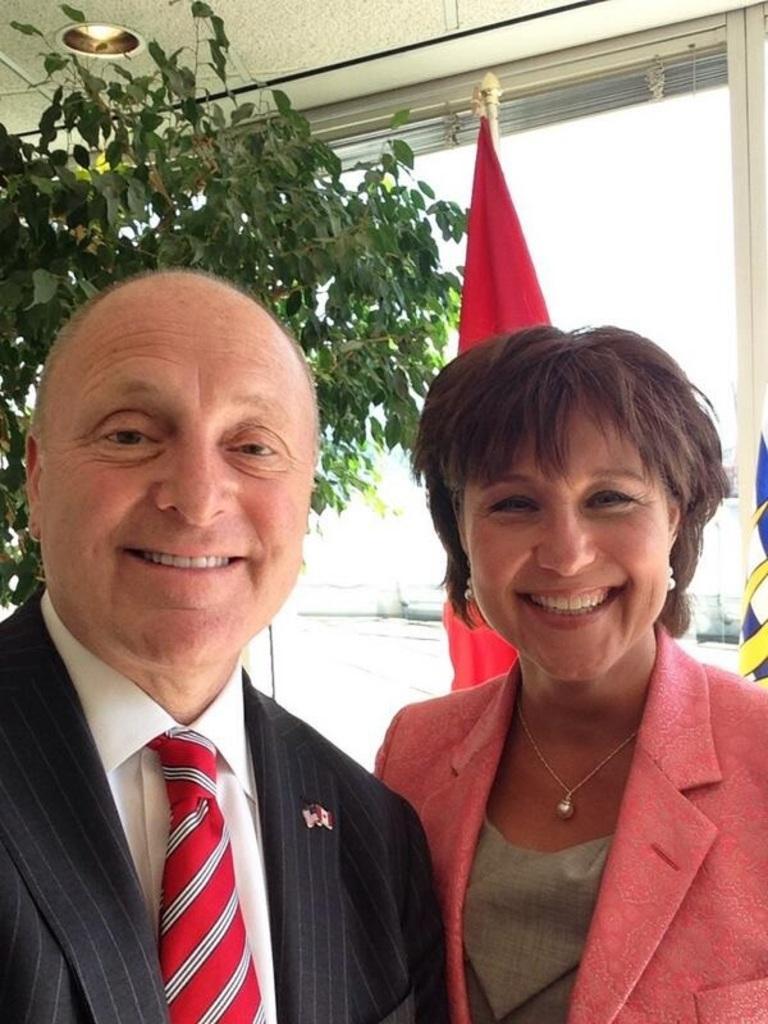Describe this image in one or two sentences. In this image we can see two persons are standing and smiling, at the back there is a tree, there is a flag, at the top there is a ceiling light, there is a glass window. 